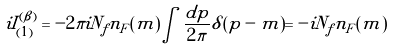Convert formula to latex. <formula><loc_0><loc_0><loc_500><loc_500>i I _ { ( 1 ) } ^ { ( \beta ) } = - 2 \pi i N _ { f } n _ { F } ( m ) \int \frac { d p } { 2 \pi } \delta ( p - m ) = - i N _ { f } n _ { F } ( m )</formula> 